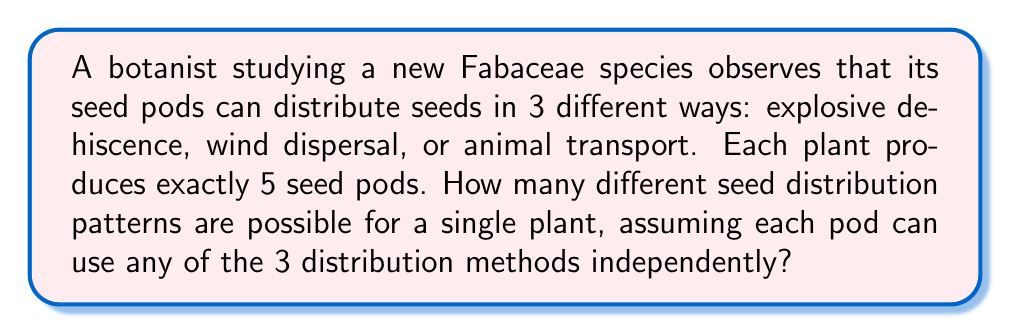What is the answer to this math problem? To solve this problem, we'll use the multiplication principle of combinatorics:

1) We have 5 seed pods, and for each pod, we need to choose one of 3 distribution methods.

2) This scenario can be modeled as making 5 independent choices, where each choice has 3 options.

3) The multiplication principle states that if we have $n$ independent events, and each event $i$ has $m_i$ possible outcomes, then the total number of possible outcomes for all events is:

   $$\prod_{i=1}^n m_i$$

4) In our case, we have 5 events (choosing a distribution method for each pod), and each event has 3 possible outcomes.

5) Therefore, the total number of possible seed distribution patterns is:

   $$3 \times 3 \times 3 \times 3 \times 3 = 3^5 = 243$$

This means there are 243 different ways the 5 seed pods on a single plant can distribute their seeds using the 3 available methods.
Answer: $3^5 = 243$ 